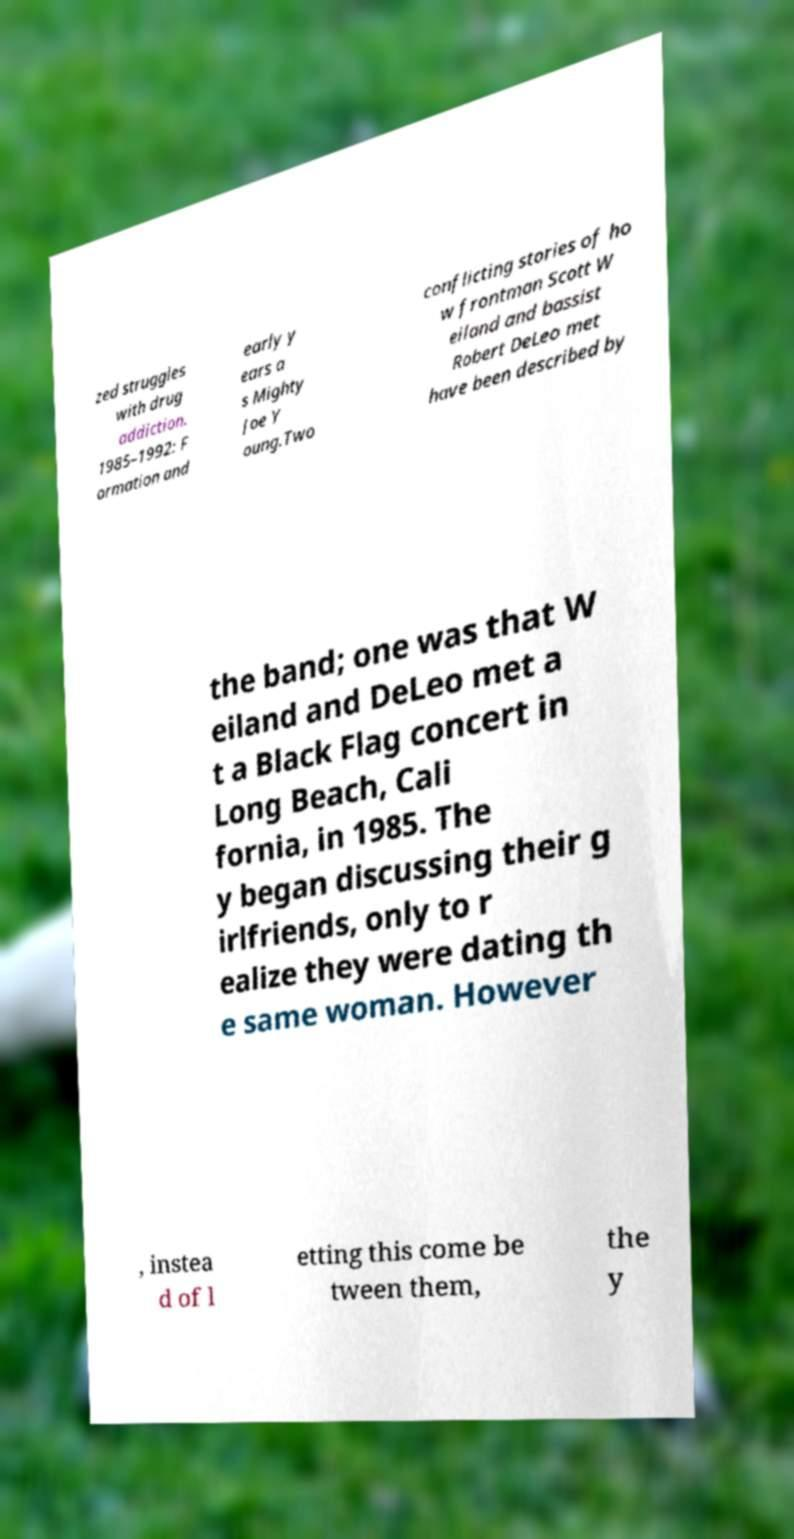I need the written content from this picture converted into text. Can you do that? zed struggles with drug addiction. 1985–1992: F ormation and early y ears a s Mighty Joe Y oung.Two conflicting stories of ho w frontman Scott W eiland and bassist Robert DeLeo met have been described by the band; one was that W eiland and DeLeo met a t a Black Flag concert in Long Beach, Cali fornia, in 1985. The y began discussing their g irlfriends, only to r ealize they were dating th e same woman. However , instea d of l etting this come be tween them, the y 